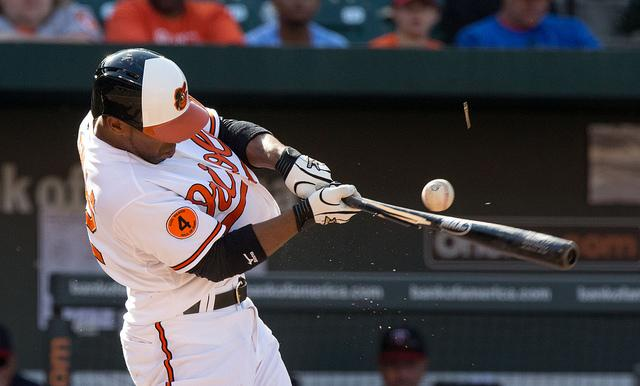Who got this ball to this place? Please explain your reasoning. pitcher. The other options don't apply to throwing the ball to the batter. 